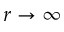<formula> <loc_0><loc_0><loc_500><loc_500>r \rightarrow \infty</formula> 